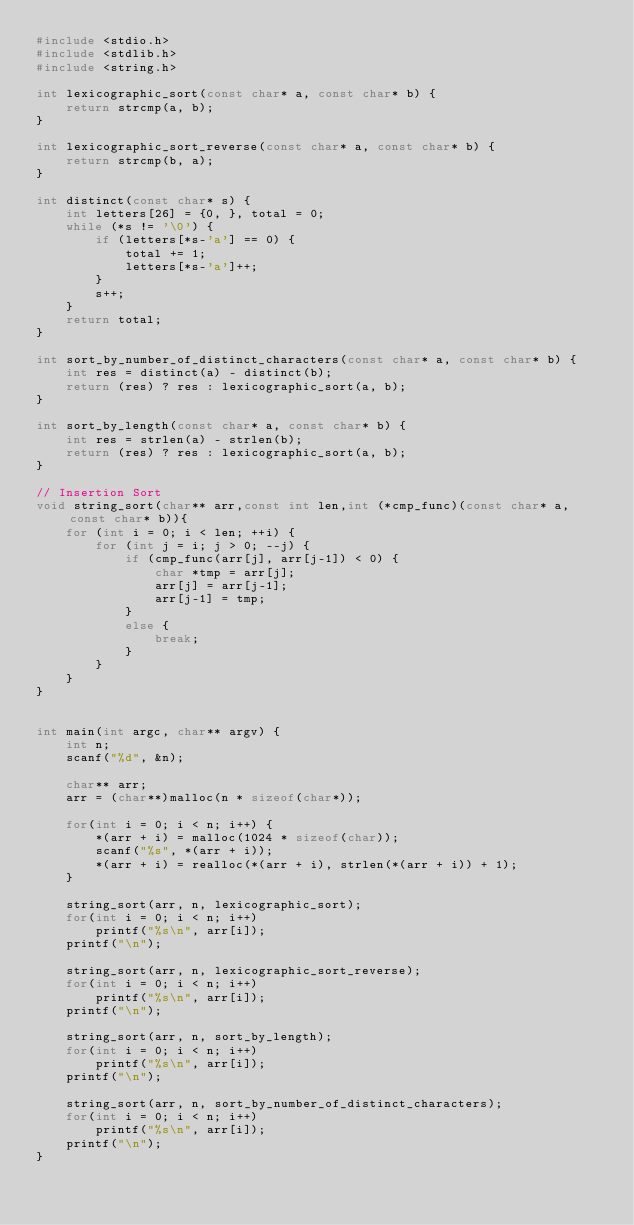<code> <loc_0><loc_0><loc_500><loc_500><_C_>#include <stdio.h>
#include <stdlib.h>
#include <string.h>

int lexicographic_sort(const char* a, const char* b) {
    return strcmp(a, b);
}

int lexicographic_sort_reverse(const char* a, const char* b) {
    return strcmp(b, a);
}

int distinct(const char* s) {
    int letters[26] = {0, }, total = 0;
    while (*s != '\0') {
        if (letters[*s-'a'] == 0) {
            total += 1;
            letters[*s-'a']++;
        }
        s++;
    }
    return total;
}

int sort_by_number_of_distinct_characters(const char* a, const char* b) {
    int res = distinct(a) - distinct(b);
    return (res) ? res : lexicographic_sort(a, b);
}

int sort_by_length(const char* a, const char* b) {
    int res = strlen(a) - strlen(b);
    return (res) ? res : lexicographic_sort(a, b);
}

// Insertion Sort
void string_sort(char** arr,const int len,int (*cmp_func)(const char* a, const char* b)){
    for (int i = 0; i < len; ++i) {
        for (int j = i; j > 0; --j) {
            if (cmp_func(arr[j], arr[j-1]) < 0) {
                char *tmp = arr[j];
                arr[j] = arr[j-1];
                arr[j-1] = tmp;
            }
            else {
                break;
            }
        }
    }
}


int main(int argc, char** argv) {
    int n;
    scanf("%d", &n);
  
    char** arr;
	arr = (char**)malloc(n * sizeof(char*));
  
    for(int i = 0; i < n; i++) {
        *(arr + i) = malloc(1024 * sizeof(char));
        scanf("%s", *(arr + i));
        *(arr + i) = realloc(*(arr + i), strlen(*(arr + i)) + 1);
    }
  
    string_sort(arr, n, lexicographic_sort);
    for(int i = 0; i < n; i++)
        printf("%s\n", arr[i]);
    printf("\n");

    string_sort(arr, n, lexicographic_sort_reverse);
    for(int i = 0; i < n; i++)
        printf("%s\n", arr[i]); 
    printf("\n");

    string_sort(arr, n, sort_by_length);
    for(int i = 0; i < n; i++)
        printf("%s\n", arr[i]);    
    printf("\n");

    string_sort(arr, n, sort_by_number_of_distinct_characters);
    for(int i = 0; i < n; i++)
        printf("%s\n", arr[i]); 
    printf("\n");
}
</code> 